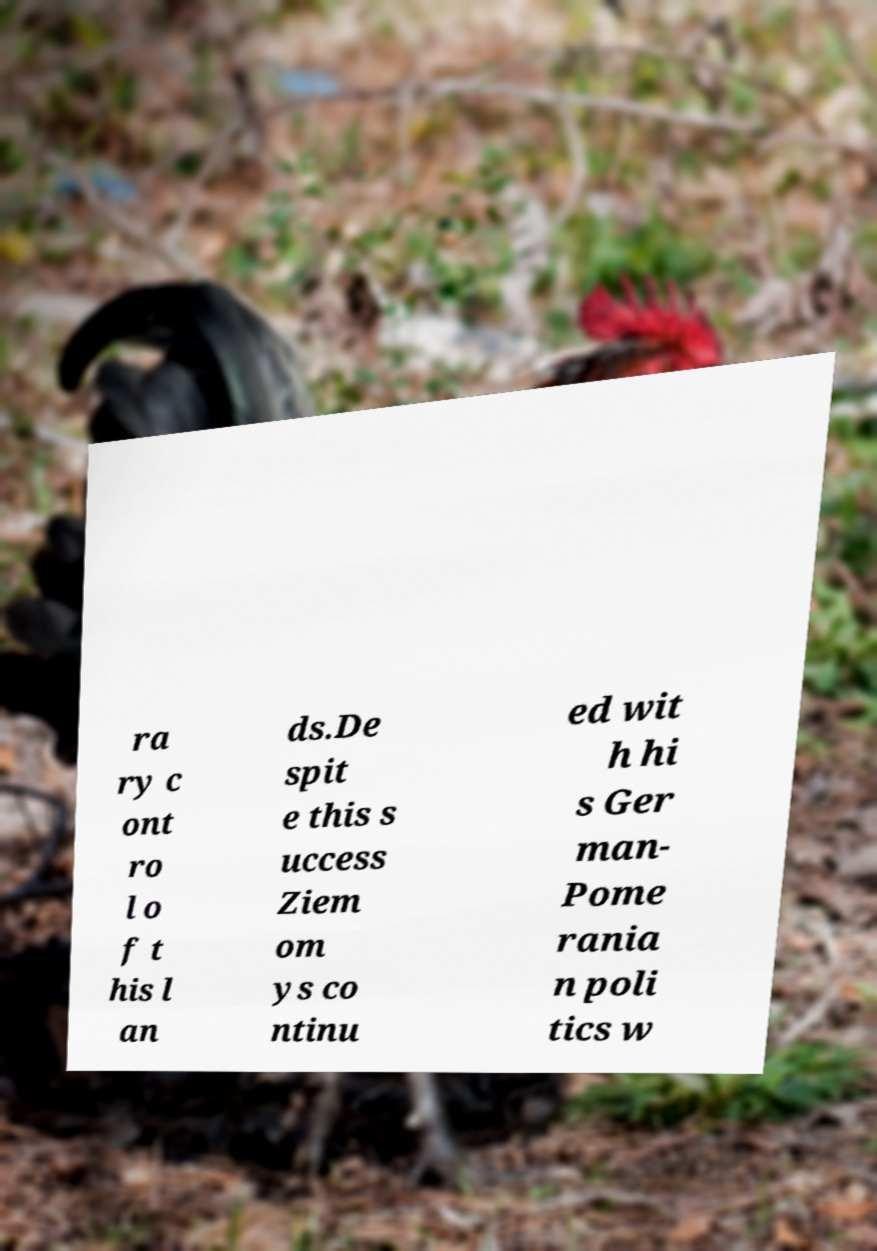What messages or text are displayed in this image? I need them in a readable, typed format. ra ry c ont ro l o f t his l an ds.De spit e this s uccess Ziem om ys co ntinu ed wit h hi s Ger man- Pome rania n poli tics w 